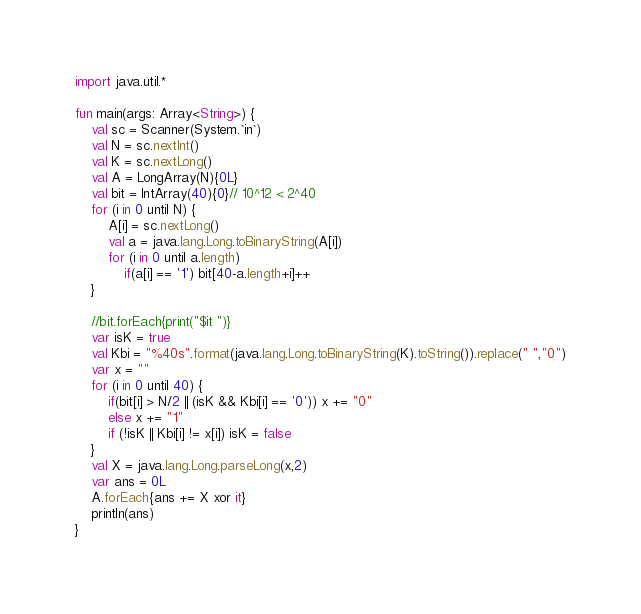Convert code to text. <code><loc_0><loc_0><loc_500><loc_500><_Kotlin_>import java.util.*

fun main(args: Array<String>) {
    val sc = Scanner(System.`in`)
    val N = sc.nextInt()
    val K = sc.nextLong()
    val A = LongArray(N){0L}
    val bit = IntArray(40){0}// 10^12 < 2^40
    for (i in 0 until N) {
        A[i] = sc.nextLong()
        val a = java.lang.Long.toBinaryString(A[i])
        for (i in 0 until a.length)
            if(a[i] == '1') bit[40-a.length+i]++ 
    }
    
    //bit.forEach{print("$it ")}
    var isK = true
    val Kbi = "%40s".format(java.lang.Long.toBinaryString(K).toString()).replace(" ","0")
    var x = ""
    for (i in 0 until 40) {
        if(bit[i] > N/2 || (isK && Kbi[i] == '0')) x += "0"
        else x += "1"
        if (!isK || Kbi[i] != x[i]) isK = false
    }
    val X = java.lang.Long.parseLong(x,2)
    var ans = 0L
    A.forEach{ans += X xor it}
    println(ans)
}</code> 